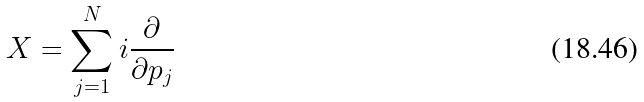<formula> <loc_0><loc_0><loc_500><loc_500>X = \sum _ { j = 1 } ^ { N } i \frac { \partial } { \partial p _ { j } }</formula> 